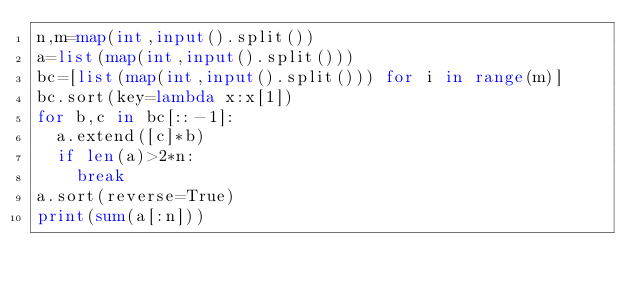Convert code to text. <code><loc_0><loc_0><loc_500><loc_500><_Python_>n,m=map(int,input().split())
a=list(map(int,input().split()))
bc=[list(map(int,input().split())) for i in range(m)]
bc.sort(key=lambda x:x[1])
for b,c in bc[::-1]:
  a.extend([c]*b)
  if len(a)>2*n:
    break
a.sort(reverse=True)
print(sum(a[:n]))</code> 